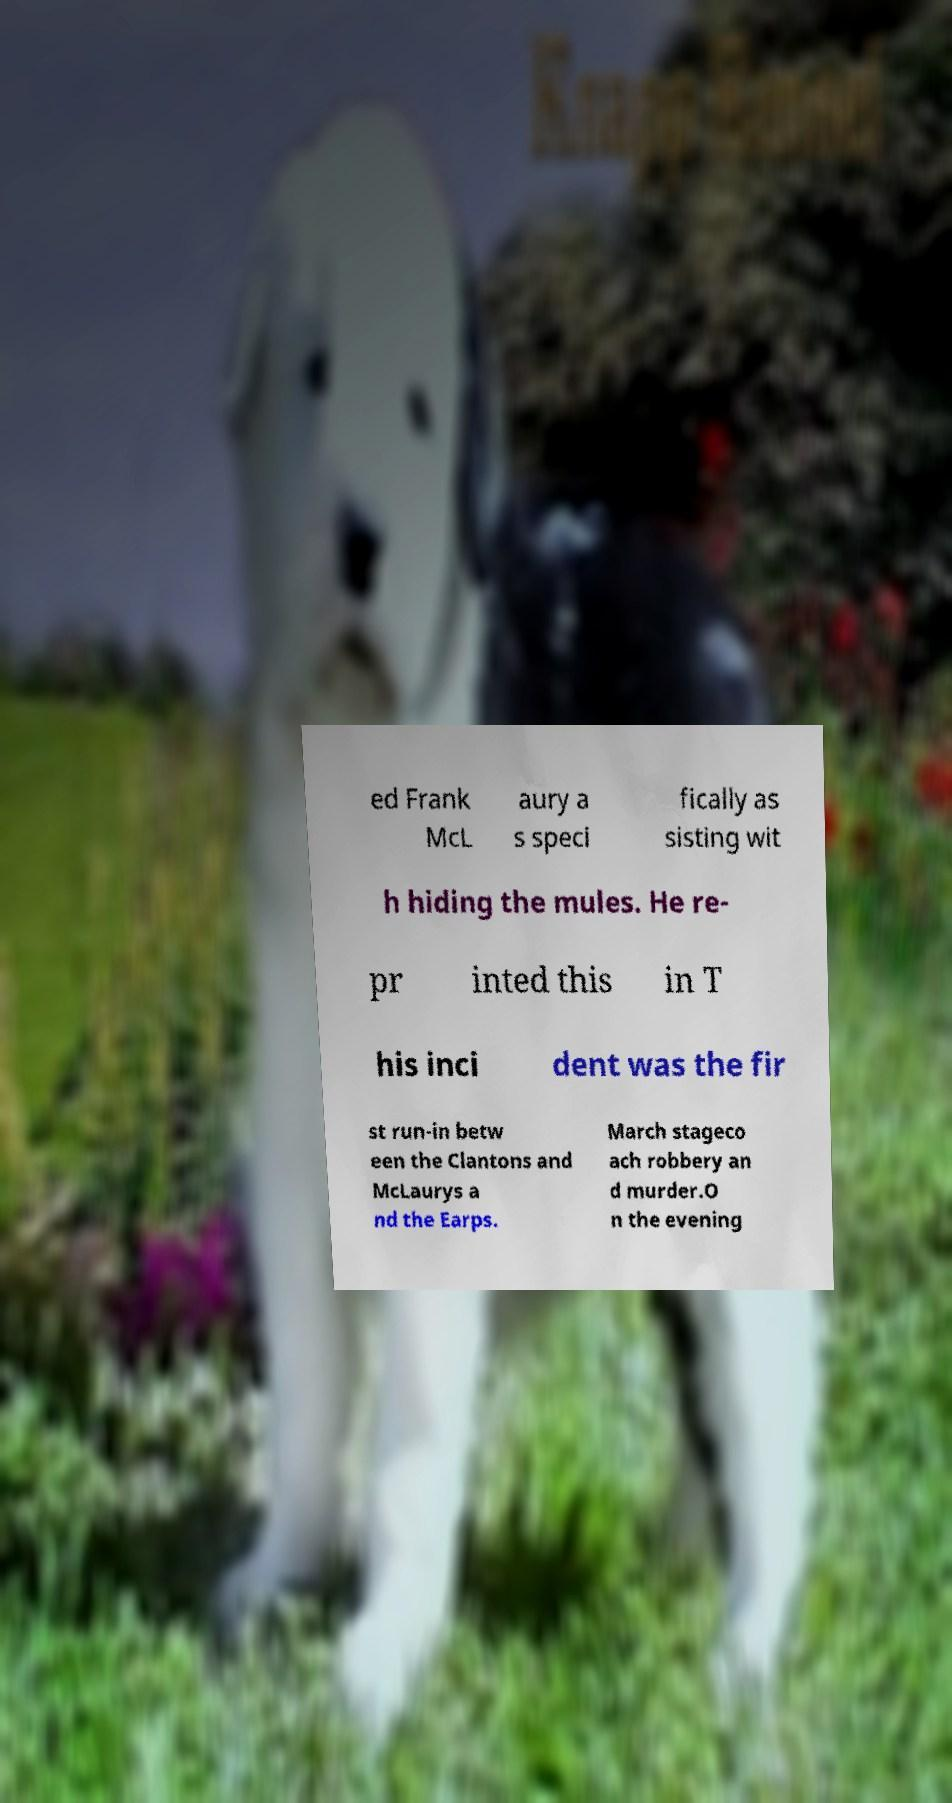Please read and relay the text visible in this image. What does it say? ed Frank McL aury a s speci fically as sisting wit h hiding the mules. He re- pr inted this in T his inci dent was the fir st run-in betw een the Clantons and McLaurys a nd the Earps. March stageco ach robbery an d murder.O n the evening 